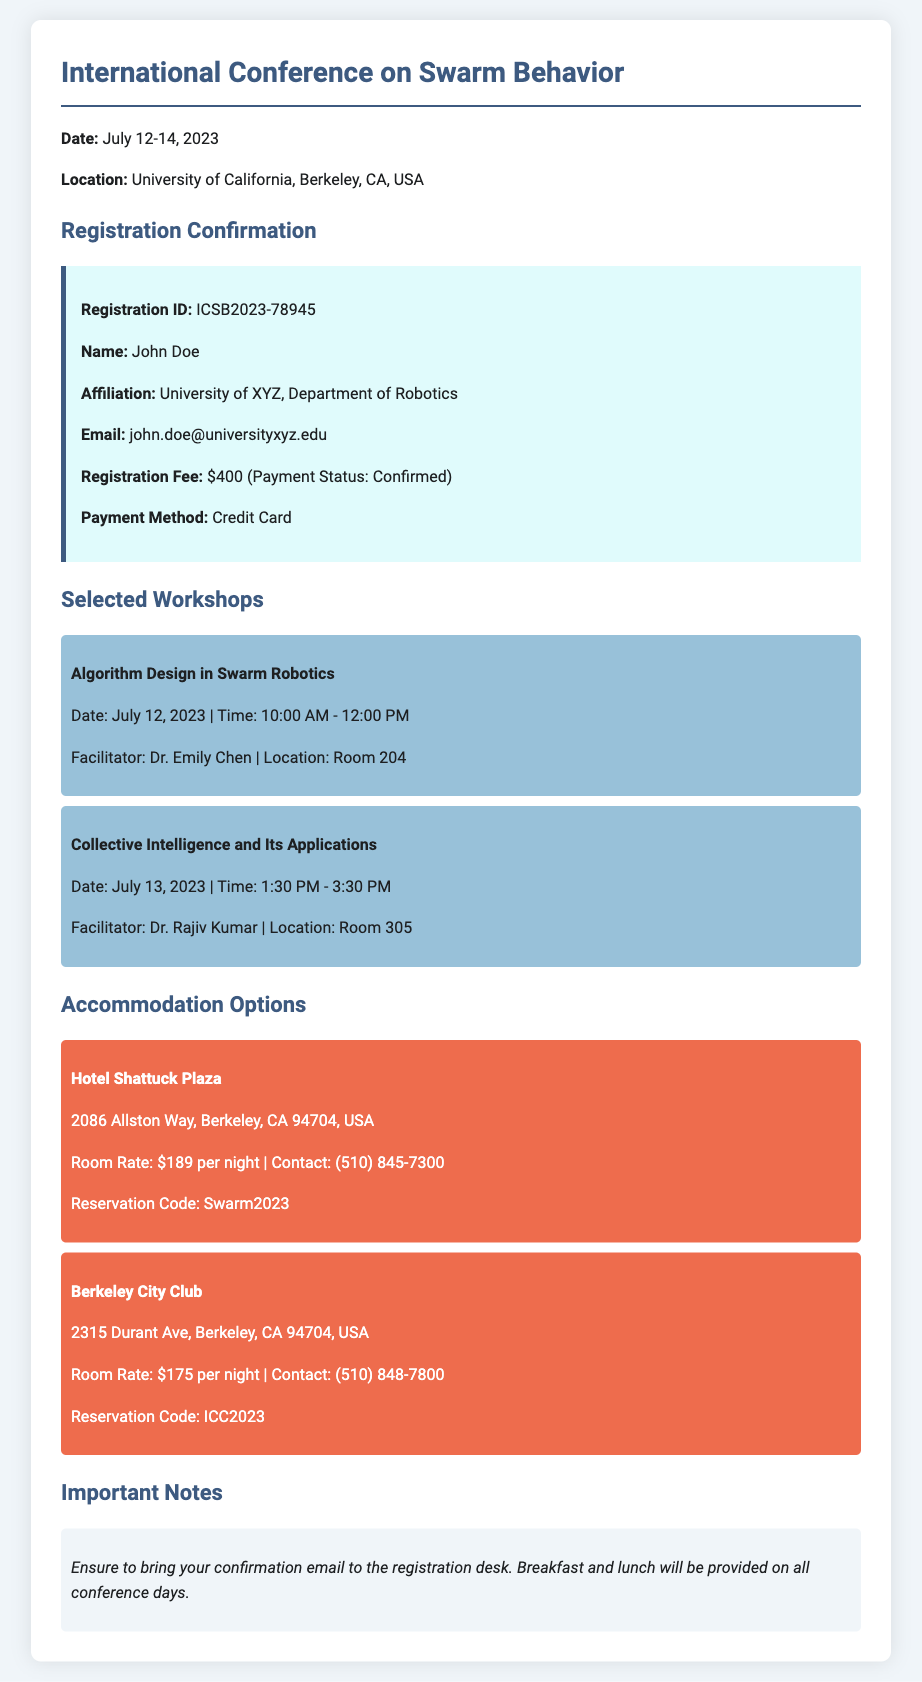What are the dates of the conference? The dates of the conference are specified in the document as July 12-14, 2023.
Answer: July 12-14, 2023 What is the registration ID for the confirmation? The registration ID is provided in the information block as ICSB2023-78945.
Answer: ICSB2023-78945 Who is the facilitator for the workshop on Algorithm Design in Swarm Robotics? The facilitator's name is included in the workshop details for algorithm design on July 12, which is Dr. Emily Chen.
Answer: Dr. Emily Chen What is the room rate at Hotel Shattuck Plaza? The room rate for Hotel Shattuck Plaza is mentioned as $189 per night.
Answer: $189 per night How many workshops are listed in the document? The number of workshops can be determined by counting the entries under selected workshops, which totals two.
Answer: 2 What is provided during all conference days? The document states that breakfast and lunch will be provided on all conference days.
Answer: Breakfast and lunch Which hotel offers a lower room rate? Comparing the room rates between the two hotels indicates that Berkeley City Club offers a lower rate at $175 per night.
Answer: $175 per night What is the payment status of the registration fee? The registration fee payment status is confirmed in the document as "Confirmed."
Answer: Confirmed What is the email address of the registrant? The email address of the registrant is included in the registration confirmation as john.doe@universityxyz.edu.
Answer: john.doe@universityxyz.edu 